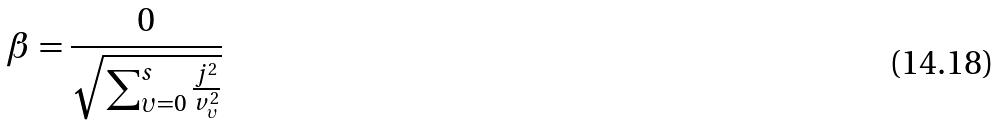<formula> <loc_0><loc_0><loc_500><loc_500>\beta = \frac { 0 } { \sqrt { \sum _ { \upsilon = 0 } ^ { s } \frac { j ^ { 2 } } { v _ { \upsilon } ^ { 2 } } } }</formula> 